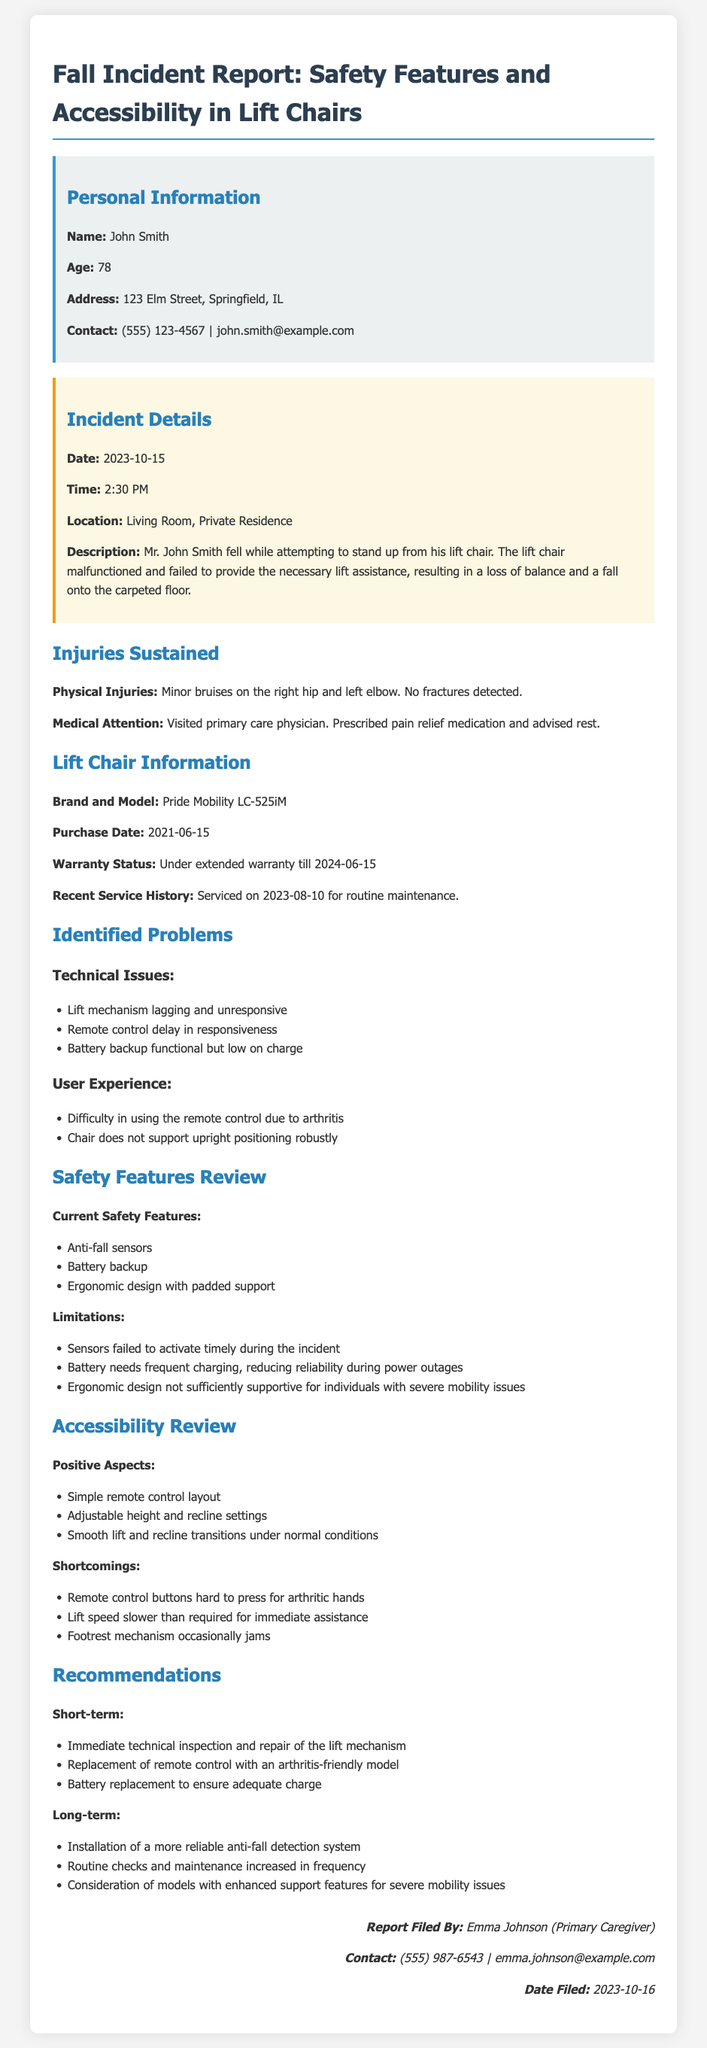What is the name of the individual involved in the incident? The document states the individual's name is John Smith.
Answer: John Smith What is the age of John Smith? According to the report, John Smith's age is explicitly given as 78.
Answer: 78 What date did the incident occur? The incident is recorded to have happened on October 15, 2023.
Answer: 2023-10-15 What brand and model of lift chair was involved in the incident? The document lists the brand and model as Pride Mobility LC-525iM.
Answer: Pride Mobility LC-525iM What were John Smith's physical injuries from the fall? The report specifies that he sustained minor bruises on the right hip and left elbow.
Answer: Minor bruises on the right hip and left elbow What technical issue was noted regarding the lift chair? The report mentions that the lift mechanism was lagging and unresponsive.
Answer: Lift mechanism lagging and unresponsive What safety feature failed during the incident? It is noted that the anti-fall sensors failed to activate timely during the incident.
Answer: Sensors failed to activate timely What is one of the recommendations for short-term improvement? One short-term recommendation is to perform an immediate technical inspection and repair of the lift mechanism.
Answer: Immediate technical inspection and repair How frequently was recent maintenance done on the lift chair? The document states that the lift chair was serviced on August 10, 2023, indicating a routine maintenance check.
Answer: 2023-08-10 